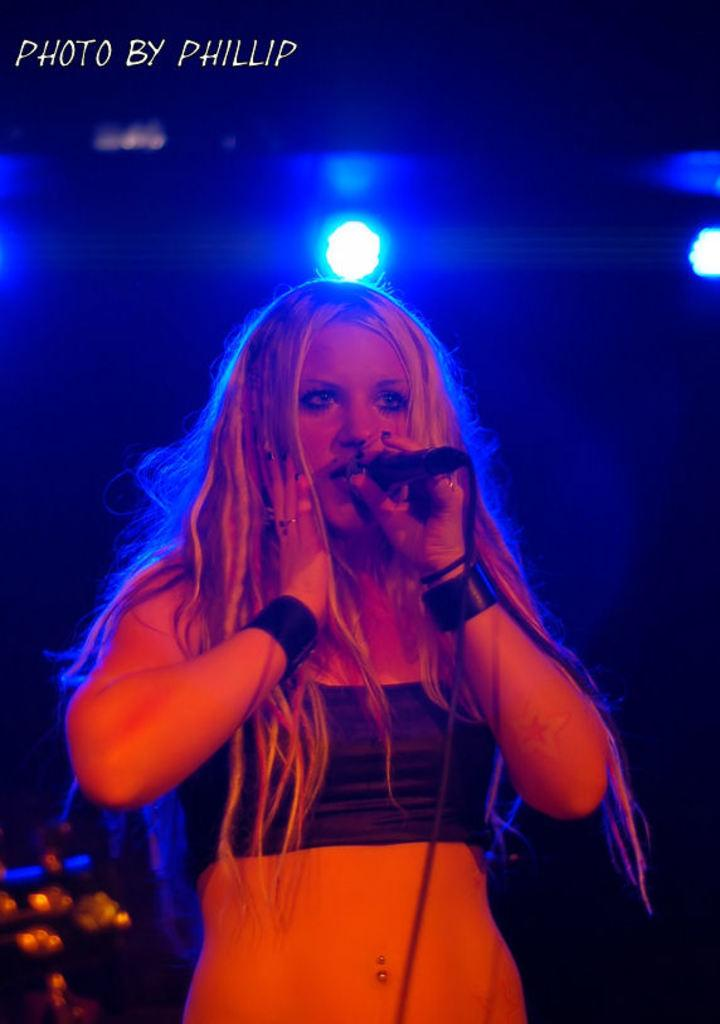Who is the main subject in the image? There is a lady in the image. What is the lady doing in the image? The lady is standing and holding a microphone. What can be seen at the top of the image? There is text at the top of the image. What type of ornament is hanging from the microphone in the image? There is no ornament hanging from the microphone in the image. Is there any eggnog being served in the image? There is no mention of eggnog or any food or drink in the image. 